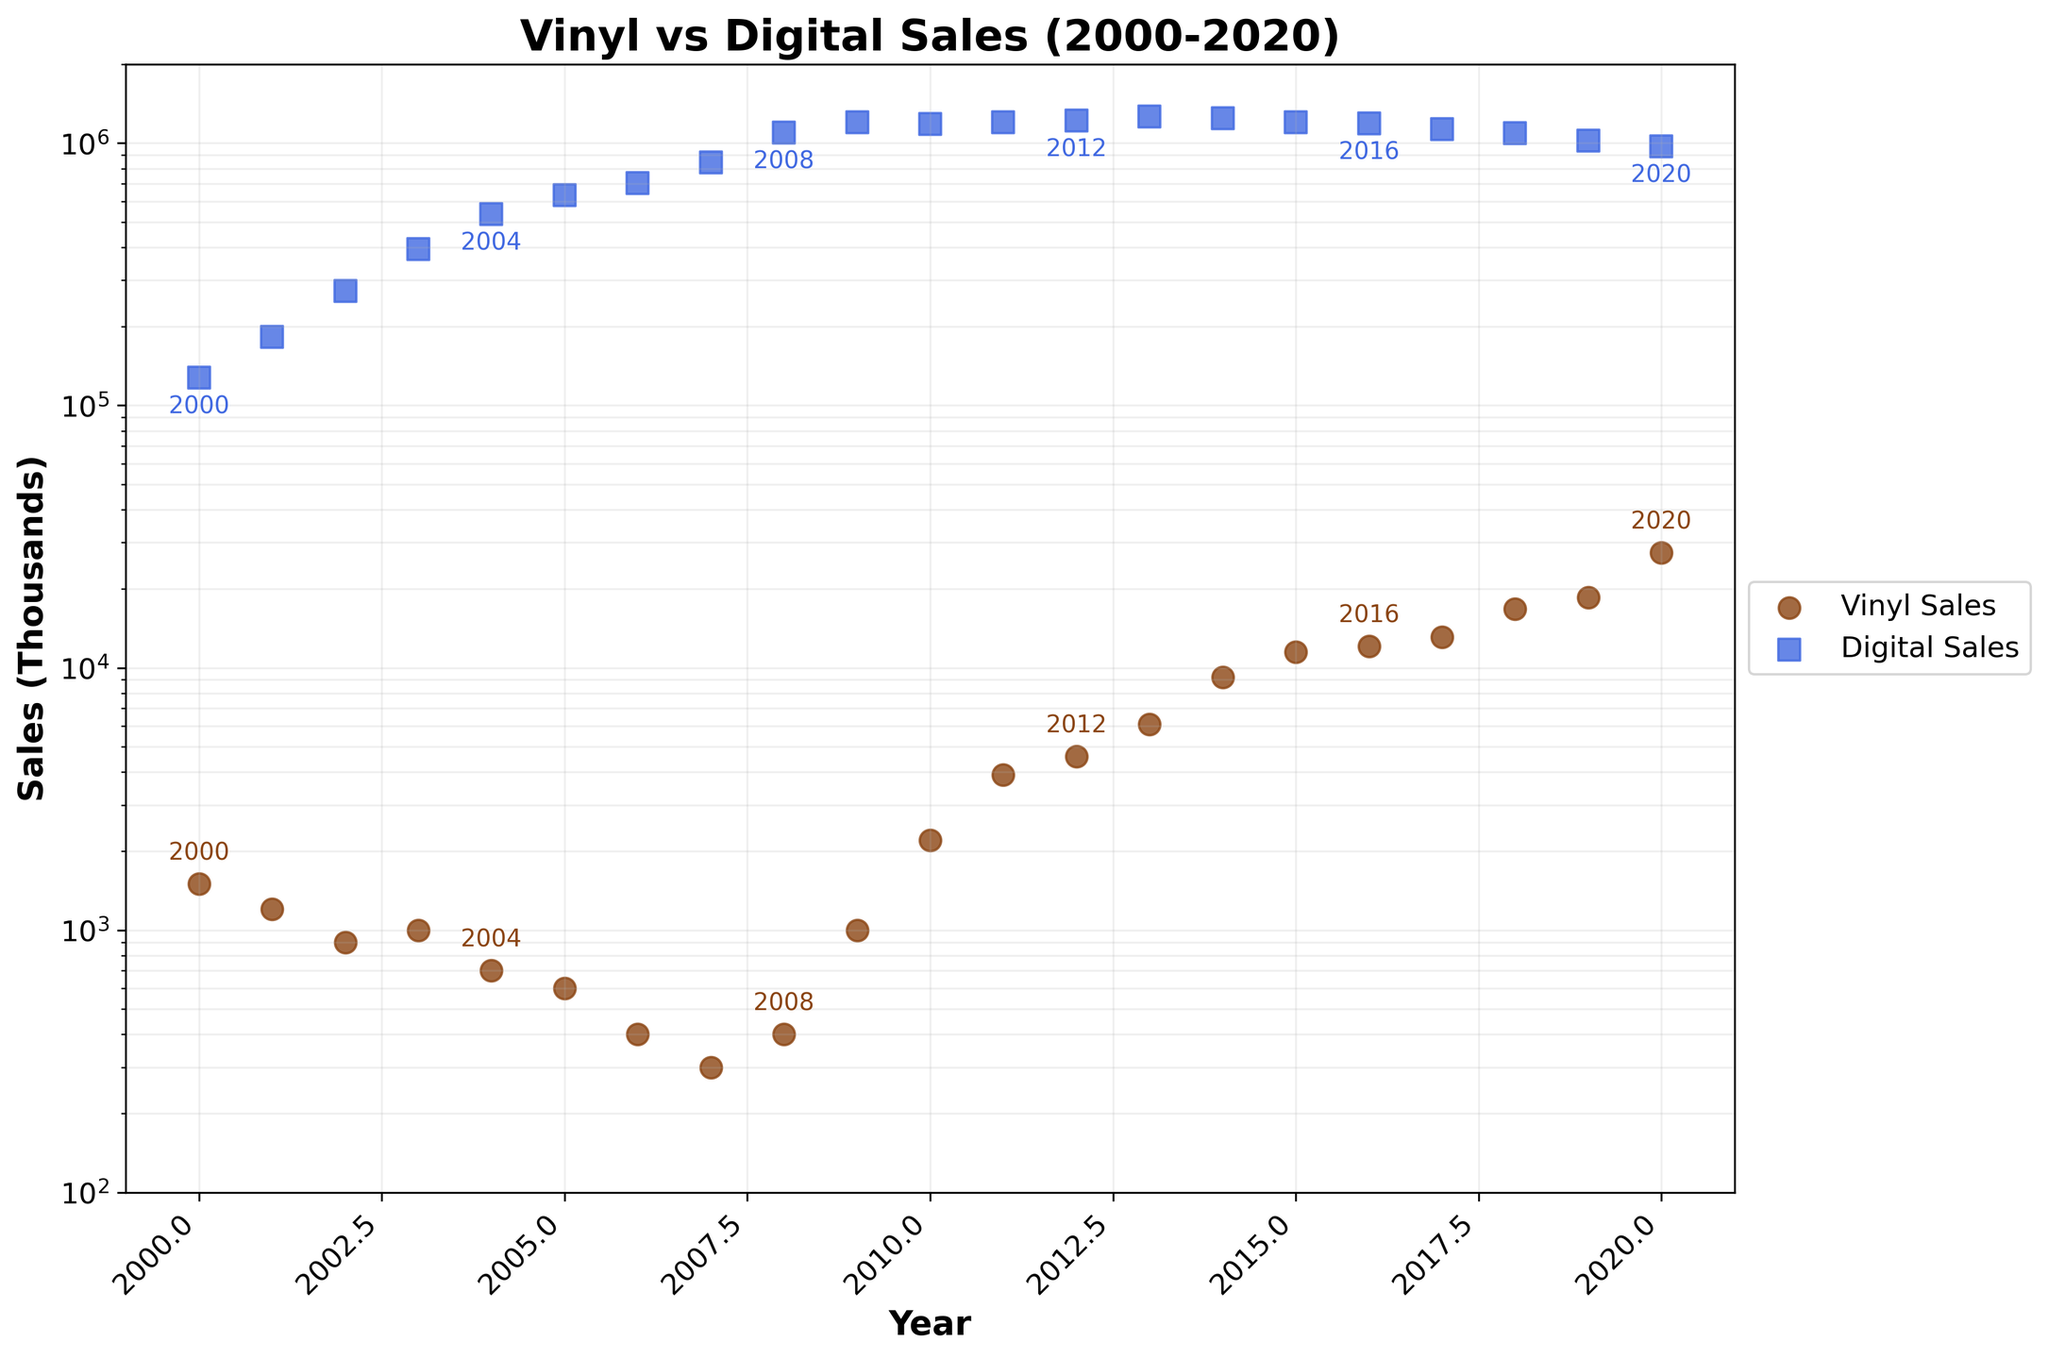What is the title of the figure? The title of the figure is typically located at the top and is used to provide a brief description of the figure’s content. In this case, the title reads "Vinyl vs Digital Sales (2000-2020)."
Answer: Vinyl vs Digital Sales (2000-2020) What are the axis labels in the figure? Axis labels describe what variables are represented on each axis. Here, the x-axis is labeled "Year" and the y-axis is labeled "Sales (Thousands)."
Answer: Year, Sales (Thousands) How many data points are there for vinyl sales and digital sales each? By counting the number of markers for each category, we can determine the number of data points. Over the period 2000-2020, we see 21 data points each for vinyl sales and digital sales.
Answer: 21 each In which year did vinyl sales exceed 10,000 thousand units for the first time? As we scan the y-axis values for vinyl sales (brown circles), we see that they exceed 10,000 (marked at 10000 on log scale) around the year 2014.
Answer: 2014 Which had higher sales in 2010, vinyl or digital? Observing the markers for 2010, the blue square (digital sales) is at around 1,185.8 thousand units whereas the brown circle (vinyl sales) is at around 2,200 thousand units. Clearly, vinyl sales were higher.
Answer: Vinyl By what factor did vinyl sales increase from 2000 to 2020? Vinyl sales in 2000 were 1,500 thousand units and in 2020 they were 27,500 thousand units. The factor increase is calculated by dividing 27,500 by 1,500.
Answer: 18.33 During which year was the smallest difference between vinyl and digital sales observed? To determine the year with the smallest difference, we look at the vertical distances between the markers for each year. Around 2009 and 2010, the markers are closest but to be precise, attempt calculations for the exact values 1000 for vinyl and 1200.6 for digital in 2009.
Answer: 2009 How did digital sales change from 2006 to 2007? Comparing the digital sales markers from 2006 and 2007, the sales values improve from 703 thousand units to 844 thousand units respectively.
Answer: Increased Which type of sales shows a consistent overall upward trend from 2000 to 2020? Observing the scatter plot, vinyl sales (brown circles) show a consistent increase over time, while digital sales (blue squares) start to decline towards 2020.
Answer: Vinyl sales 